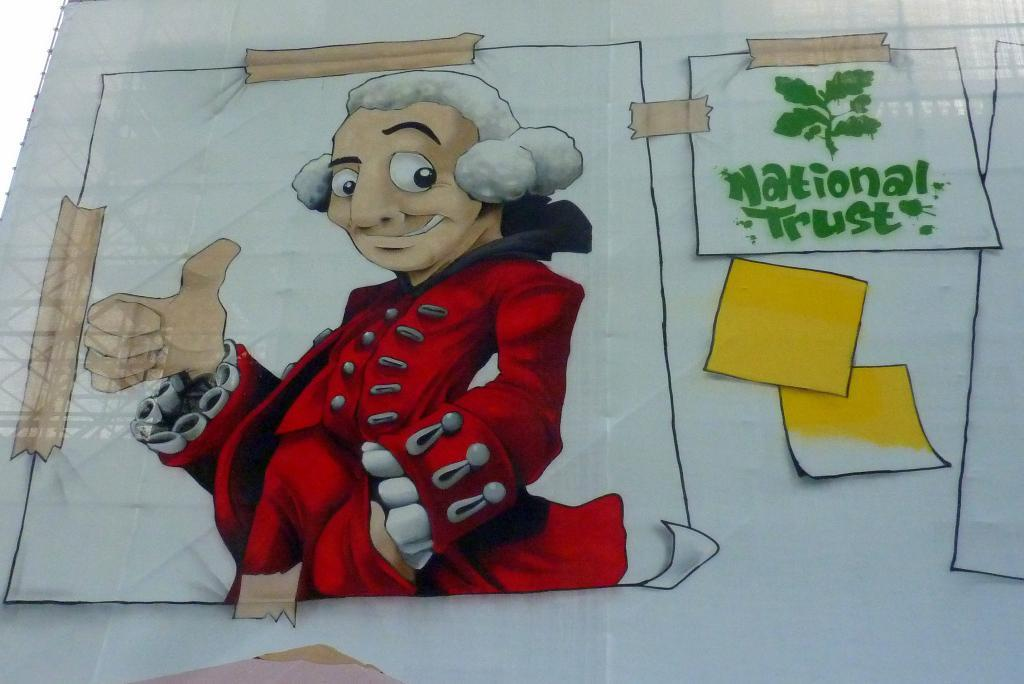Provide a one-sentence caption for the provided image. A fake poster stating National Trust next to a man in red. 